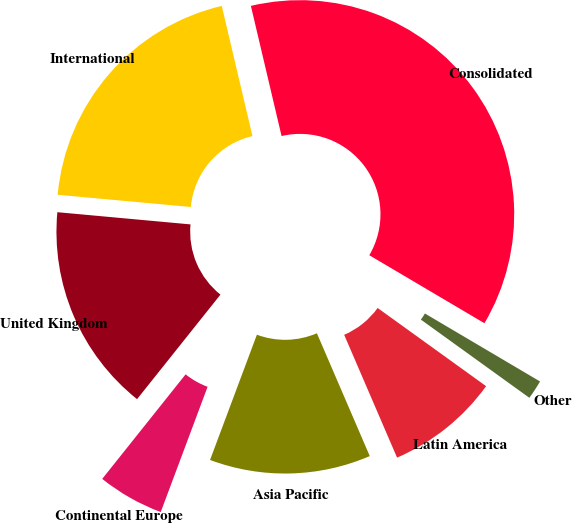Convert chart to OTSL. <chart><loc_0><loc_0><loc_500><loc_500><pie_chart><fcel>Consolidated<fcel>International<fcel>United Kingdom<fcel>Continental Europe<fcel>Asia Pacific<fcel>Latin America<fcel>Other<nl><fcel>37.18%<fcel>19.86%<fcel>15.74%<fcel>5.02%<fcel>12.17%<fcel>8.59%<fcel>1.45%<nl></chart> 